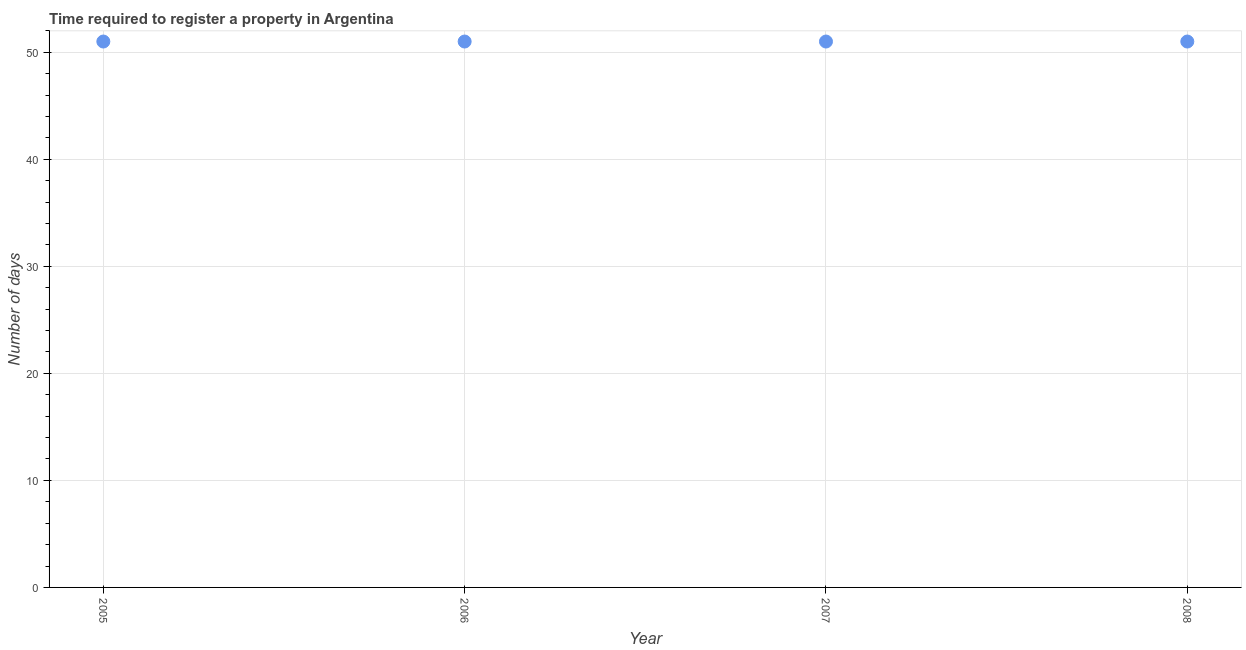What is the number of days required to register property in 2005?
Give a very brief answer. 51. Across all years, what is the maximum number of days required to register property?
Offer a terse response. 51. In which year was the number of days required to register property minimum?
Give a very brief answer. 2005. What is the sum of the number of days required to register property?
Keep it short and to the point. 204. What is the difference between the number of days required to register property in 2005 and 2007?
Ensure brevity in your answer.  0. What is the median number of days required to register property?
Ensure brevity in your answer.  51. In how many years, is the number of days required to register property greater than 18 days?
Offer a very short reply. 4. Do a majority of the years between 2007 and 2008 (inclusive) have number of days required to register property greater than 24 days?
Offer a very short reply. Yes. What is the ratio of the number of days required to register property in 2005 to that in 2007?
Provide a short and direct response. 1. Is the number of days required to register property in 2006 less than that in 2007?
Offer a terse response. No. Is the difference between the number of days required to register property in 2006 and 2007 greater than the difference between any two years?
Your answer should be compact. Yes. What is the difference between the highest and the second highest number of days required to register property?
Your answer should be compact. 0. In how many years, is the number of days required to register property greater than the average number of days required to register property taken over all years?
Offer a terse response. 0. Does the number of days required to register property monotonically increase over the years?
Keep it short and to the point. No. How many years are there in the graph?
Your response must be concise. 4. What is the difference between two consecutive major ticks on the Y-axis?
Provide a short and direct response. 10. Are the values on the major ticks of Y-axis written in scientific E-notation?
Make the answer very short. No. Does the graph contain any zero values?
Offer a very short reply. No. Does the graph contain grids?
Your answer should be compact. Yes. What is the title of the graph?
Offer a terse response. Time required to register a property in Argentina. What is the label or title of the Y-axis?
Keep it short and to the point. Number of days. What is the Number of days in 2005?
Give a very brief answer. 51. What is the Number of days in 2007?
Your response must be concise. 51. What is the difference between the Number of days in 2005 and 2007?
Your response must be concise. 0. What is the difference between the Number of days in 2005 and 2008?
Make the answer very short. 0. What is the difference between the Number of days in 2006 and 2008?
Your answer should be very brief. 0. What is the difference between the Number of days in 2007 and 2008?
Provide a succinct answer. 0. What is the ratio of the Number of days in 2005 to that in 2007?
Keep it short and to the point. 1. What is the ratio of the Number of days in 2006 to that in 2007?
Offer a terse response. 1. What is the ratio of the Number of days in 2006 to that in 2008?
Keep it short and to the point. 1. 